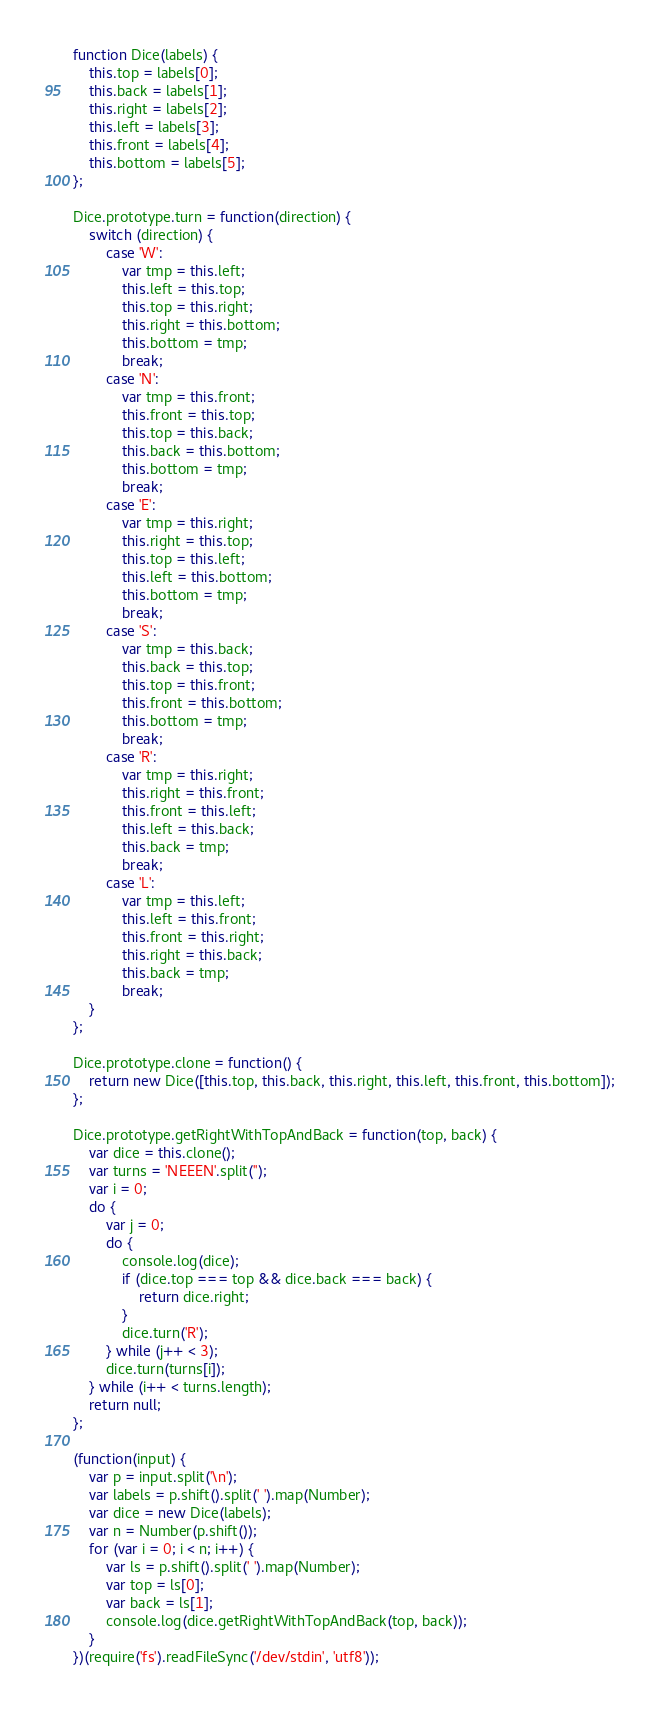Convert code to text. <code><loc_0><loc_0><loc_500><loc_500><_JavaScript_>function Dice(labels) {
    this.top = labels[0];
    this.back = labels[1];
    this.right = labels[2];
    this.left = labels[3];
    this.front = labels[4];
    this.bottom = labels[5];
};

Dice.prototype.turn = function(direction) {
    switch (direction) {
        case 'W':
            var tmp = this.left;
            this.left = this.top;
            this.top = this.right;
            this.right = this.bottom;
            this.bottom = tmp;
            break;
        case 'N':
            var tmp = this.front;
            this.front = this.top;
            this.top = this.back;
            this.back = this.bottom;
            this.bottom = tmp;
            break;
        case 'E':
            var tmp = this.right;
            this.right = this.top;
            this.top = this.left;
            this.left = this.bottom;
            this.bottom = tmp;
            break;
        case 'S':
            var tmp = this.back;
            this.back = this.top;
            this.top = this.front;
            this.front = this.bottom;
            this.bottom = tmp;
            break;
        case 'R':
            var tmp = this.right;
            this.right = this.front;
            this.front = this.left;
            this.left = this.back;
            this.back = tmp;
            break;
        case 'L':
            var tmp = this.left;
            this.left = this.front;
            this.front = this.right;
            this.right = this.back;
            this.back = tmp;
            break;
    }
};

Dice.prototype.clone = function() {
    return new Dice([this.top, this.back, this.right, this.left, this.front, this.bottom]);
};

Dice.prototype.getRightWithTopAndBack = function(top, back) {
    var dice = this.clone();
    var turns = 'NEEEN'.split('');
    var i = 0;
    do {
        var j = 0;
        do {
            console.log(dice);
            if (dice.top === top && dice.back === back) {
                return dice.right;
            }
            dice.turn('R');
        } while (j++ < 3);
        dice.turn(turns[i]);
    } while (i++ < turns.length);
    return null;
};

(function(input) {
    var p = input.split('\n');
    var labels = p.shift().split(' ').map(Number);
    var dice = new Dice(labels);
    var n = Number(p.shift());
    for (var i = 0; i < n; i++) {
        var ls = p.shift().split(' ').map(Number);
        var top = ls[0];
        var back = ls[1];
        console.log(dice.getRightWithTopAndBack(top, back));
    }
})(require('fs').readFileSync('/dev/stdin', 'utf8'));</code> 